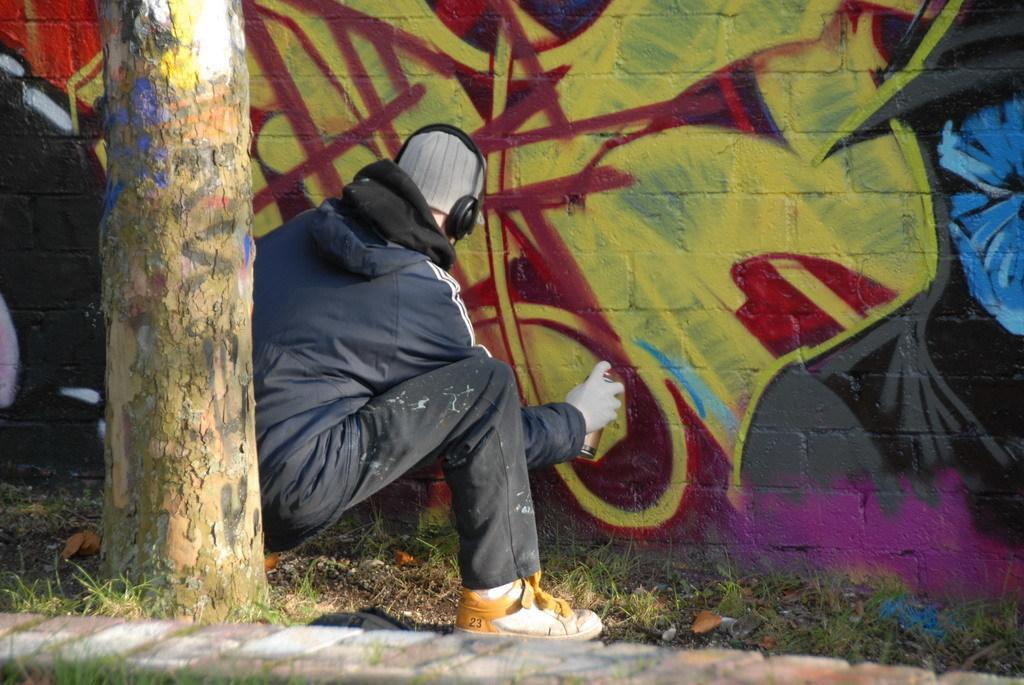Describe this image in one or two sentences. In this image there is a branch, person, grass and wall. Person wore a jacket, headset and holding a spray bottle. Graffiti is on the wall.   